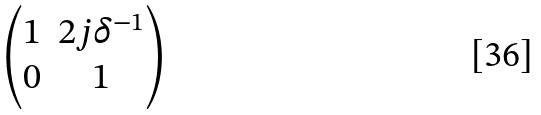Convert formula to latex. <formula><loc_0><loc_0><loc_500><loc_500>\begin{pmatrix} 1 & 2 j \delta ^ { - 1 } \\ 0 & 1 \\ \end{pmatrix}</formula> 